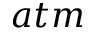Convert formula to latex. <formula><loc_0><loc_0><loc_500><loc_500>a t m</formula> 